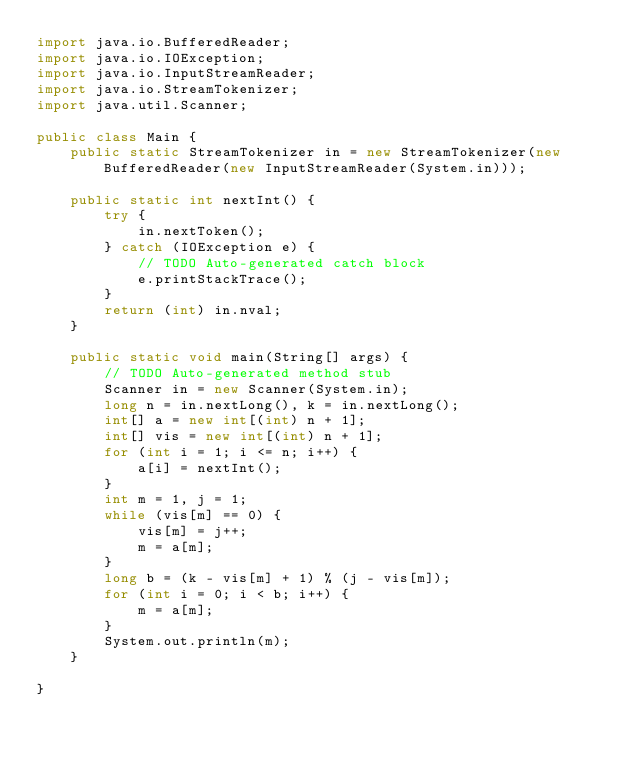<code> <loc_0><loc_0><loc_500><loc_500><_Java_>import java.io.BufferedReader;
import java.io.IOException;
import java.io.InputStreamReader;
import java.io.StreamTokenizer;
import java.util.Scanner;

public class Main {
    public static StreamTokenizer in = new StreamTokenizer(new BufferedReader(new InputStreamReader(System.in)));

    public static int nextInt() {
        try {
            in.nextToken();
        } catch (IOException e) {
            // TODO Auto-generated catch block
            e.printStackTrace();
        }
        return (int) in.nval;
    }

    public static void main(String[] args) {
        // TODO Auto-generated method stub
        Scanner in = new Scanner(System.in);
        long n = in.nextLong(), k = in.nextLong();
        int[] a = new int[(int) n + 1];
        int[] vis = new int[(int) n + 1];
        for (int i = 1; i <= n; i++) {
            a[i] = nextInt();
        }
        int m = 1, j = 1;
        while (vis[m] == 0) {
            vis[m] = j++;
            m = a[m];
        }
        long b = (k - vis[m] + 1) % (j - vis[m]);
        for (int i = 0; i < b; i++) {
            m = a[m];
        }
        System.out.println(m);
    }

}
</code> 